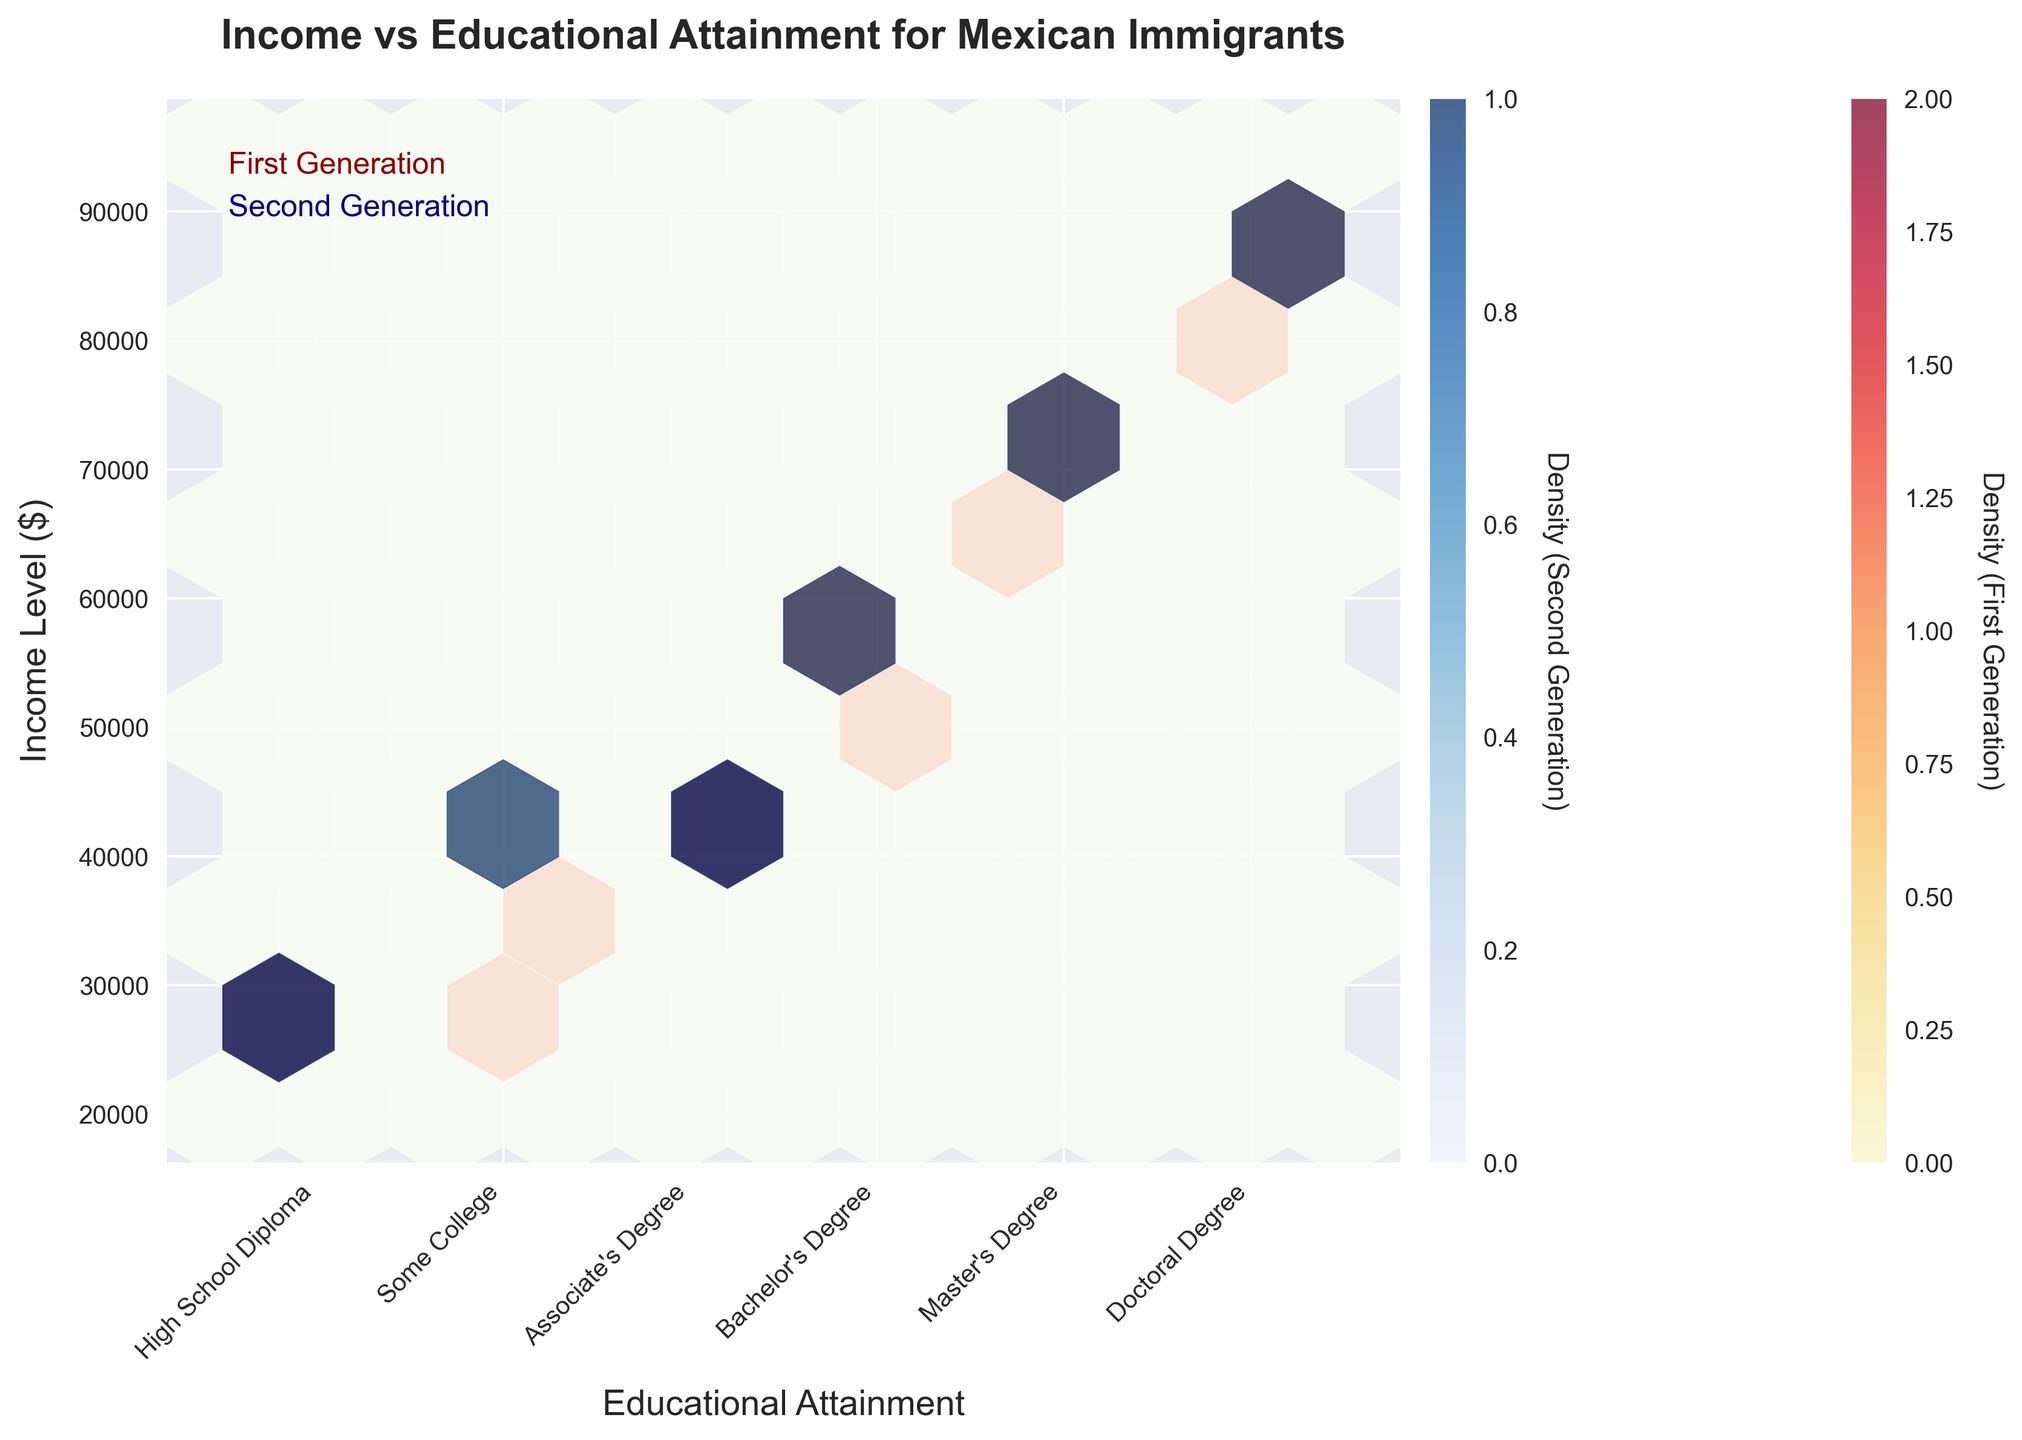What is the title of the plot? The title of the plot is displayed at the top of the figure in a bold font. It provides an overview of what the plot represents.
Answer: Income vs Educational Attainment for Mexican Immigrants What are the ranges of income levels shown on the y-axis? The y-axis ranges from 20,000 to 95,000, as indicated by the labels on the axis.
Answer: 20,000 to 95,000 Which generation has the higher density of individuals with a Master's Degree? The density is represented by the color intensity in the hexbin plot. By looking at the Master's Degree level (5), the second generation (represented in blue) has a higher density compared to the first generation (represented in yellow to red).
Answer: Second Generation Between which educational attainment levels do both generations show the greatest overlap in income densities? To find the overlap, examine where the colors for both generations are most intense around the same areas of the y-axis. The greatest overlap appears between educational levels 2 (Some College) and 4 (Bachelor’s Degree) with incomes ranging from approximately 30,000 to 60,000.
Answer: Some College and Bachelor's Degree What education level and income bracket do the highest densities occur for both generations? For the first generation, the highest density is at the Bachelor's Degree (4) level and an income around 50,000 to 55,000. For the second generation, the highest density is at the Master's Degree (5) level and an income around 75,000.
Answer: Bachelor's Degree at 50,000 to 55,000 for First Generation, Master's Degree at 75,000 for Second Generation Which generation has a higher maximum income, and what is that income? The hexbin plot shows income levels up to approximately 90,000 for the second generation, whereas the first generation reaches up to approximately 85,000.
Answer: Second Generation at 90,000 How does the income range of individuals with a Bachelor's Degree differ between the first and second generations? For the first generation, individuals with a Bachelor's Degree have incomes ranging from about 50,000 to 55,000. For the second generation, incomes with the same educational level range from about 60,000 to 65,000.
Answer: First Generation: 50,000 to 55,000; Second Generation: 60,000 to 65,000 Which generation generally shows higher income levels at each corresponding educational attainment level? By examining the hexbin colors along each educational level on the plot, it's evident that the second generation (blue) generally has higher income levels compared to the first generation (yellow to red) across all levels.
Answer: Second Generation What does the color intensity in hexbin plots represent in this figure? The color intensity in hexbin plots represents the density of data points within each hexbin. The more intense the color, the higher the density of individuals with that combination of educational attainment and income level.
Answer: Density of data points 